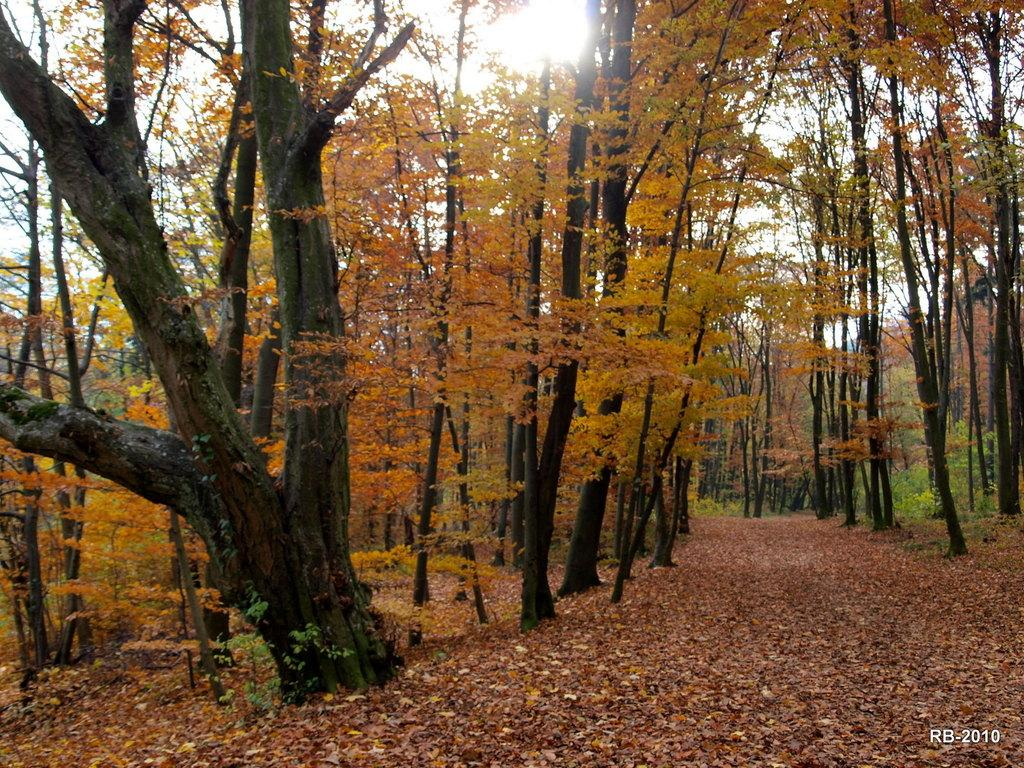What is present on the path in the foreground of the image? There are leaves on the path in the foreground of the image. What type of vegetation can be seen in the image? There are trees visible in the image. What is visible in the background of the image? The sky is visible in the image. Can the sun be seen in the sky? Yes, the sun is observable in the sky. What type of father can be seen holding a flame in the image? There is no father or flame present in the image; it features leaves on a path, trees, sky, and the sun. 